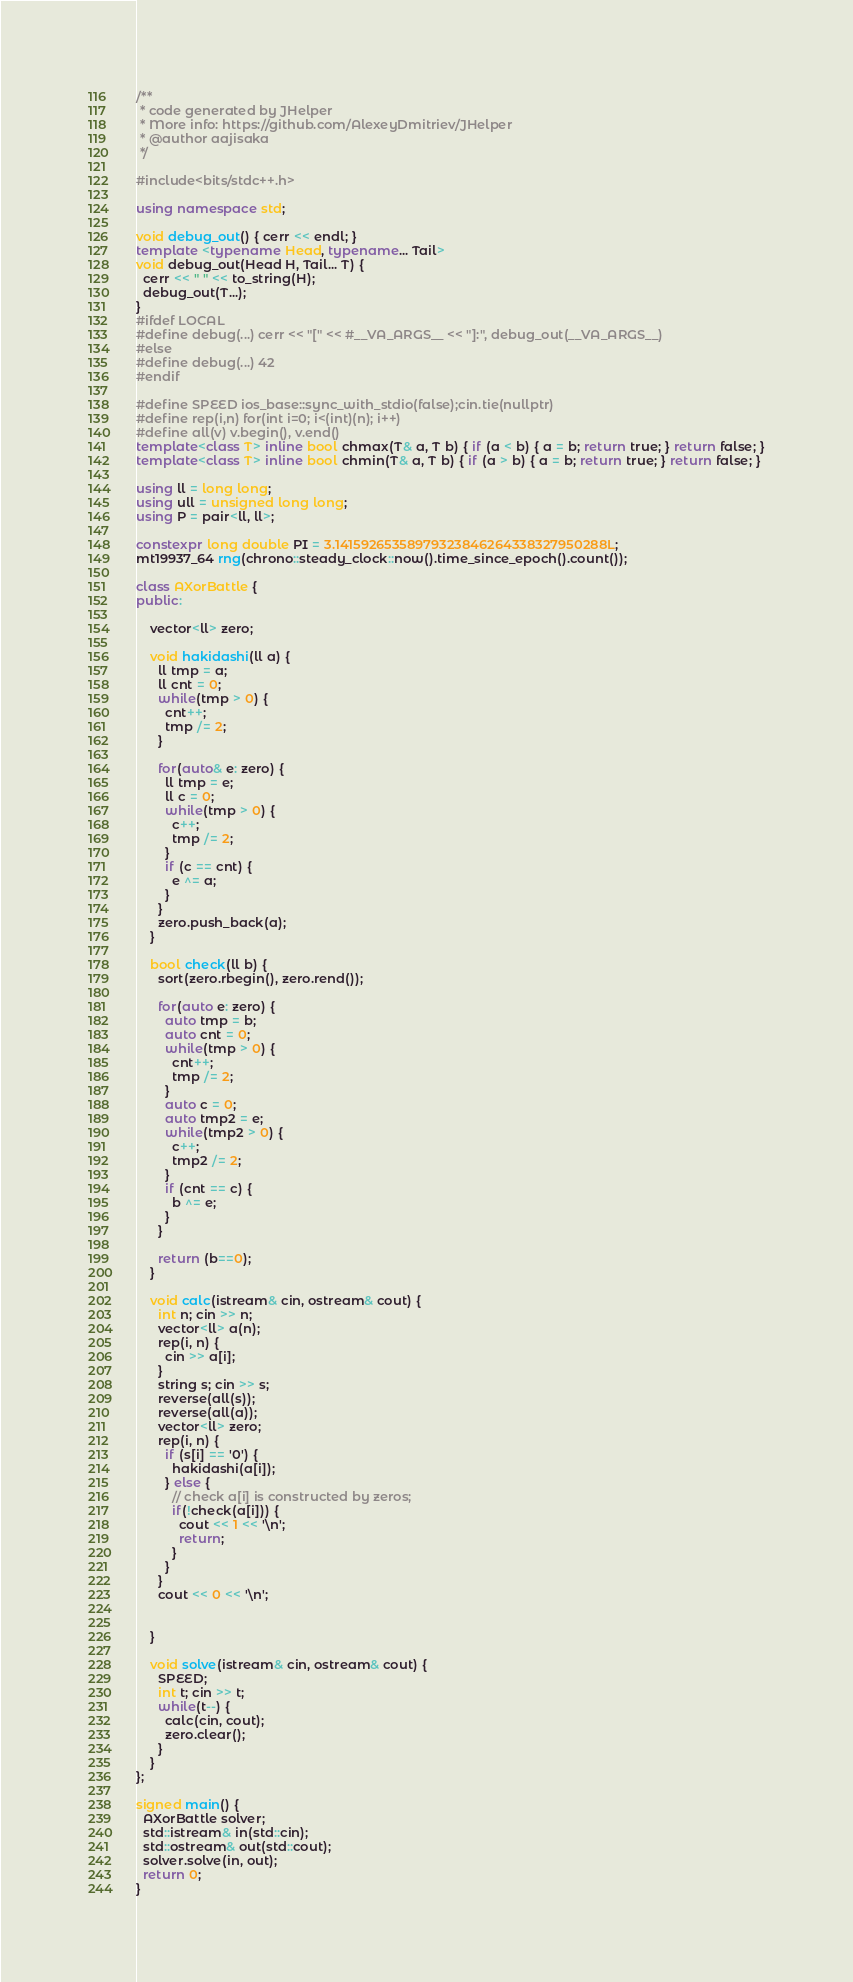<code> <loc_0><loc_0><loc_500><loc_500><_C++_>/**
 * code generated by JHelper
 * More info: https://github.com/AlexeyDmitriev/JHelper
 * @author aajisaka
 */

#include<bits/stdc++.h>

using namespace std;

void debug_out() { cerr << endl; }
template <typename Head, typename... Tail>
void debug_out(Head H, Tail... T) {
  cerr << " " << to_string(H);
  debug_out(T...);
}
#ifdef LOCAL
#define debug(...) cerr << "[" << #__VA_ARGS__ << "]:", debug_out(__VA_ARGS__)
#else
#define debug(...) 42
#endif

#define SPEED ios_base::sync_with_stdio(false);cin.tie(nullptr)
#define rep(i,n) for(int i=0; i<(int)(n); i++)
#define all(v) v.begin(), v.end()
template<class T> inline bool chmax(T& a, T b) { if (a < b) { a = b; return true; } return false; }
template<class T> inline bool chmin(T& a, T b) { if (a > b) { a = b; return true; } return false; }

using ll = long long;
using ull = unsigned long long;
using P = pair<ll, ll>;

constexpr long double PI = 3.14159265358979323846264338327950288L;
mt19937_64 rng(chrono::steady_clock::now().time_since_epoch().count());

class AXorBattle {
public:

    vector<ll> zero;

    void hakidashi(ll a) {
      ll tmp = a;
      ll cnt = 0;
      while(tmp > 0) {
        cnt++;
        tmp /= 2;
      }

      for(auto& e: zero) {
        ll tmp = e;
        ll c = 0;
        while(tmp > 0) {
          c++;
          tmp /= 2;
        }
        if (c == cnt) {
          e ^= a;
        }
      }
      zero.push_back(a);
    }

    bool check(ll b) {
      sort(zero.rbegin(), zero.rend());

      for(auto e: zero) {
        auto tmp = b;
        auto cnt = 0;
        while(tmp > 0) {
          cnt++;
          tmp /= 2;
        }
        auto c = 0;
        auto tmp2 = e;
        while(tmp2 > 0) {
          c++;
          tmp2 /= 2;
        }
        if (cnt == c) {
          b ^= e;
        }
      }

      return (b==0);
    }

    void calc(istream& cin, ostream& cout) {
      int n; cin >> n;
      vector<ll> a(n);
      rep(i, n) {
        cin >> a[i];
      }
      string s; cin >> s;
      reverse(all(s));
      reverse(all(a));
      vector<ll> zero;
      rep(i, n) {
        if (s[i] == '0') {
          hakidashi(a[i]);
        } else {
          // check a[i] is constructed by zeros;
          if(!check(a[i])) {
            cout << 1 << '\n';
            return;
          }
        }
      }
      cout << 0 << '\n';


    }

    void solve(istream& cin, ostream& cout) {
      SPEED;
      int t; cin >> t;
      while(t--) {
        calc(cin, cout);
        zero.clear();
      }
    }
};

signed main() {
  AXorBattle solver;
  std::istream& in(std::cin);
  std::ostream& out(std::cout);
  solver.solve(in, out);
  return 0;
}</code> 